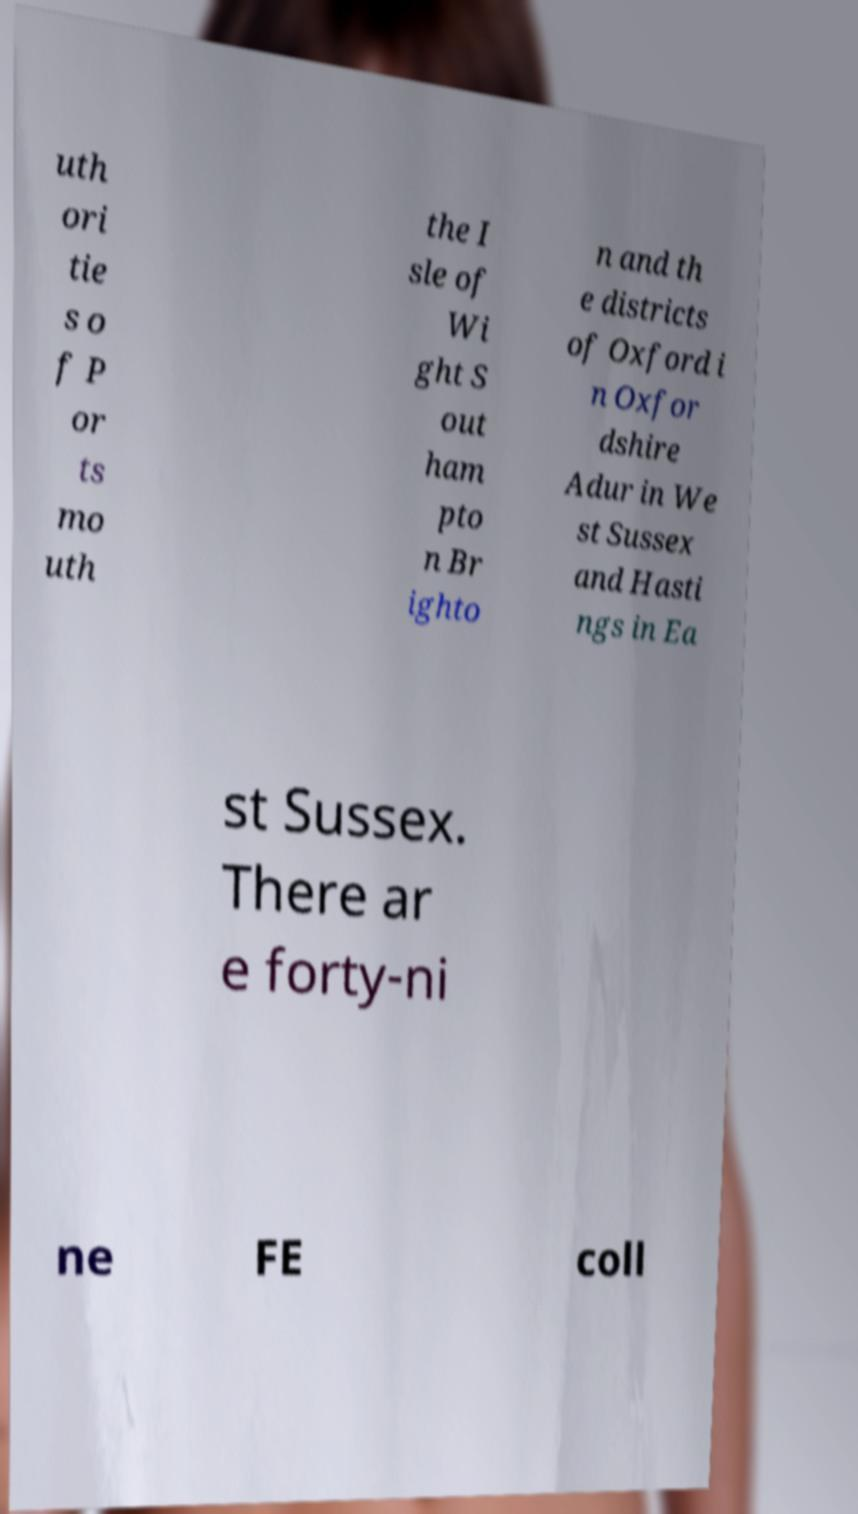Could you assist in decoding the text presented in this image and type it out clearly? uth ori tie s o f P or ts mo uth the I sle of Wi ght S out ham pto n Br ighto n and th e districts of Oxford i n Oxfor dshire Adur in We st Sussex and Hasti ngs in Ea st Sussex. There ar e forty-ni ne FE coll 